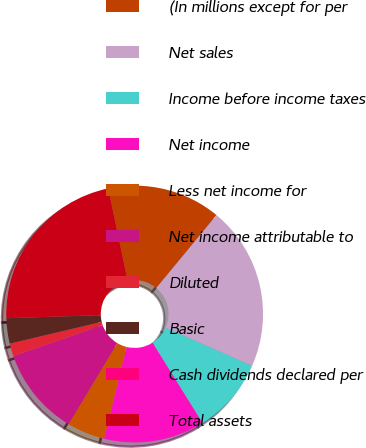Convert chart. <chart><loc_0><loc_0><loc_500><loc_500><pie_chart><fcel>(In millions except for per<fcel>Net sales<fcel>Income before income taxes<fcel>Net income<fcel>Less net income for<fcel>Net income attributable to<fcel>Diluted<fcel>Basic<fcel>Cash dividends declared per<fcel>Total assets<nl><fcel>14.29%<fcel>20.63%<fcel>9.52%<fcel>12.7%<fcel>4.76%<fcel>11.11%<fcel>1.59%<fcel>3.18%<fcel>0.0%<fcel>22.22%<nl></chart> 